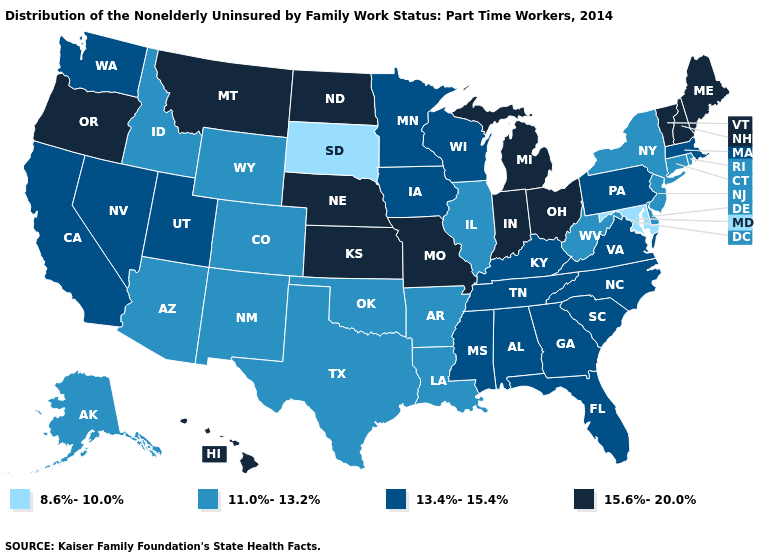What is the value of Washington?
Be succinct. 13.4%-15.4%. What is the highest value in states that border South Dakota?
Keep it brief. 15.6%-20.0%. Which states have the highest value in the USA?
Write a very short answer. Hawaii, Indiana, Kansas, Maine, Michigan, Missouri, Montana, Nebraska, New Hampshire, North Dakota, Ohio, Oregon, Vermont. Which states have the lowest value in the USA?
Give a very brief answer. Maryland, South Dakota. Name the states that have a value in the range 11.0%-13.2%?
Be succinct. Alaska, Arizona, Arkansas, Colorado, Connecticut, Delaware, Idaho, Illinois, Louisiana, New Jersey, New Mexico, New York, Oklahoma, Rhode Island, Texas, West Virginia, Wyoming. Does Vermont have the highest value in the USA?
Answer briefly. Yes. Does New Hampshire have the lowest value in the USA?
Answer briefly. No. What is the highest value in the USA?
Write a very short answer. 15.6%-20.0%. What is the highest value in the USA?
Quick response, please. 15.6%-20.0%. Does Connecticut have a higher value than Utah?
Keep it brief. No. Name the states that have a value in the range 11.0%-13.2%?
Give a very brief answer. Alaska, Arizona, Arkansas, Colorado, Connecticut, Delaware, Idaho, Illinois, Louisiana, New Jersey, New Mexico, New York, Oklahoma, Rhode Island, Texas, West Virginia, Wyoming. Does Indiana have a higher value than New Hampshire?
Write a very short answer. No. How many symbols are there in the legend?
Short answer required. 4. Among the states that border Rhode Island , which have the highest value?
Keep it brief. Massachusetts. Name the states that have a value in the range 13.4%-15.4%?
Keep it brief. Alabama, California, Florida, Georgia, Iowa, Kentucky, Massachusetts, Minnesota, Mississippi, Nevada, North Carolina, Pennsylvania, South Carolina, Tennessee, Utah, Virginia, Washington, Wisconsin. 